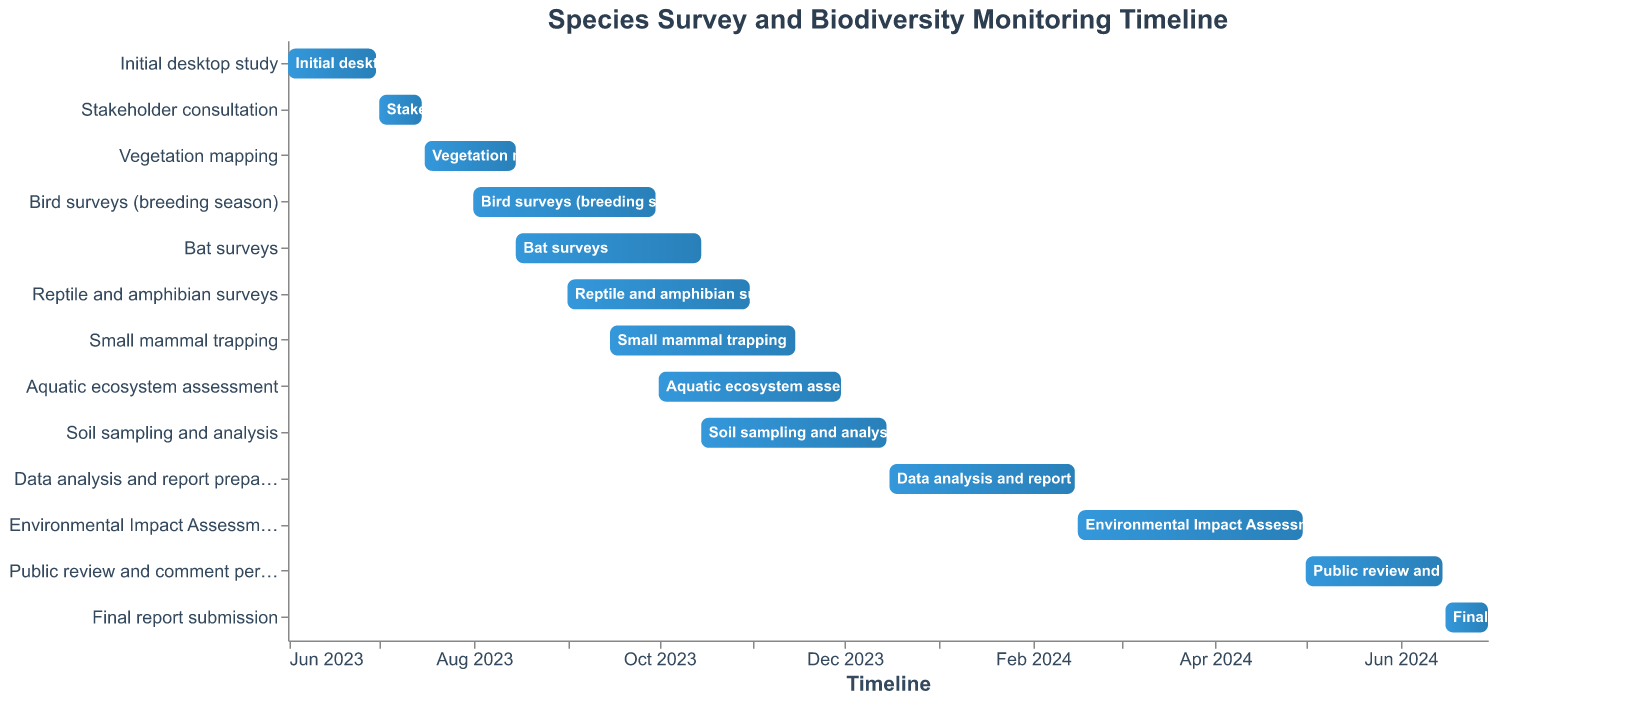How long does the Initial desktop study take? The Initial desktop study starts on June 1, 2023, and ends on June 30, 2023. The duration can be calculated by finding the difference between the end date and the start date.
Answer: 30 days Which survey has the longest duration? To determine the survey with the longest duration, compare the time spans of all surveys. The Environmental Impact Assessment drafting, lasting from February 16, 2024, to April 30, 2024, stands out as the longest.
Answer: Environmental Impact Assessment drafting When does the Small mammal trapping survey begin and end? The Small mammal trapping survey starts on September 15, 2023, and ends on November 15, 2023.
Answer: September 15, 2023, to November 15, 2023 How much time is allocated for Public review and comment period? The Public review and comment period starts on May 1, 2024, and ends on June 15, 2024. The duration is found by calculating the difference between these dates.
Answer: 45 days Which tasks are ongoing in October 2023? Review the timeline for tasks that overlap with October 2023. These include Bat surveys, Reptile and amphibian surveys, Small mammal trapping, Aquatic ecosystem assessment, and Soil sampling and analysis.
Answer: Bat surveys, Reptile and amphibian surveys, Small mammal trapping, Aquatic ecosystem assessment, Soil sampling and analysis What is the overlap period between Bird surveys and Bat surveys? Bird surveys run from August 1, 2023, to September 30, 2023, and Bat surveys from August 15, 2023, to October 15, 2023. The overlapping period is from August 15, 2023, to September 30, 2023.
Answer: August 15, 2023, to September 30, 2023 How many days are there between the end of the Final report submission and the start of the Public review and comment period? The Final report submission ends on June 30, 2024, and the Public review and comment period starts on May 1, 2024. Calculate the difference between these two dates.
Answer: -61 days (note the period follows the review) What tasks are planned to start in August 2023? Check the timeline for the tasks starting in August 2023. Bird surveys (breeding season) on August 1, 2023, and Bat surveys on August 15, 2023.
Answer: Bird surveys, Bat surveys Which survey starts immediately after the Vegetation mapping ends? Vegetation mapping ends on August 15, 2023. The next task starting after this date is Bat surveys, starting the same day.
Answer: Bat surveys 